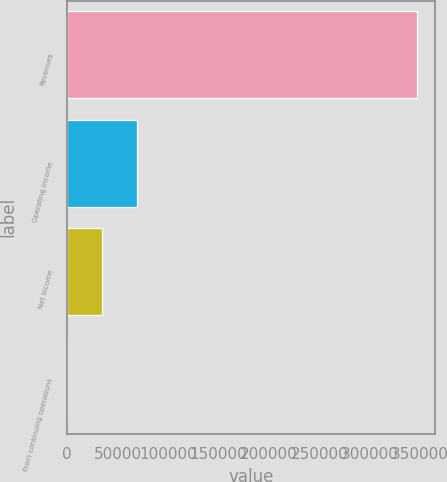<chart> <loc_0><loc_0><loc_500><loc_500><bar_chart><fcel>Revenues<fcel>Operating income<fcel>Net income<fcel>From continuing operations<nl><fcel>347321<fcel>69464.5<fcel>34732.4<fcel>0.36<nl></chart> 